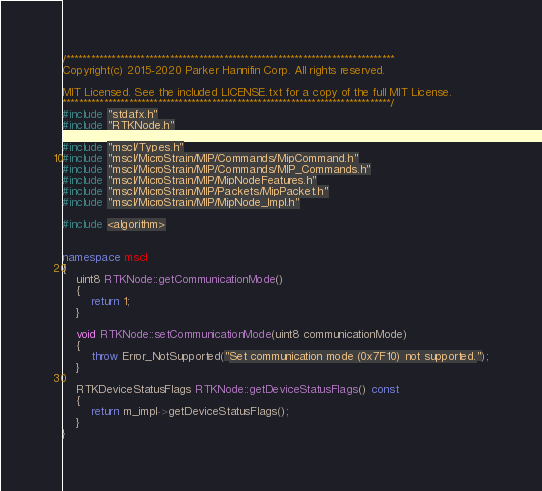Convert code to text. <code><loc_0><loc_0><loc_500><loc_500><_C++_>/*******************************************************************************
Copyright(c) 2015-2020 Parker Hannifin Corp. All rights reserved.

MIT Licensed. See the included LICENSE.txt for a copy of the full MIT License.
*******************************************************************************/
#include "stdafx.h"
#include "RTKNode.h"

#include "mscl/Types.h"
#include "mscl/MicroStrain/MIP/Commands/MipCommand.h"
#include "mscl/MicroStrain/MIP/Commands/MIP_Commands.h"
#include "mscl/MicroStrain/MIP/MipNodeFeatures.h"
#include "mscl/MicroStrain/MIP/Packets/MipPacket.h"
#include "mscl/MicroStrain/MIP/MipNode_Impl.h"

#include <algorithm>


namespace mscl
{
    uint8 RTKNode::getCommunicationMode()
    {
        return 1;
    }

    void RTKNode::setCommunicationMode(uint8 communicationMode)
    {
        throw Error_NotSupported("Set communication mode (0x7F10) not supported.");
    }

    RTKDeviceStatusFlags RTKNode::getDeviceStatusFlags() const
    {
        return m_impl->getDeviceStatusFlags();
    }
}
</code> 